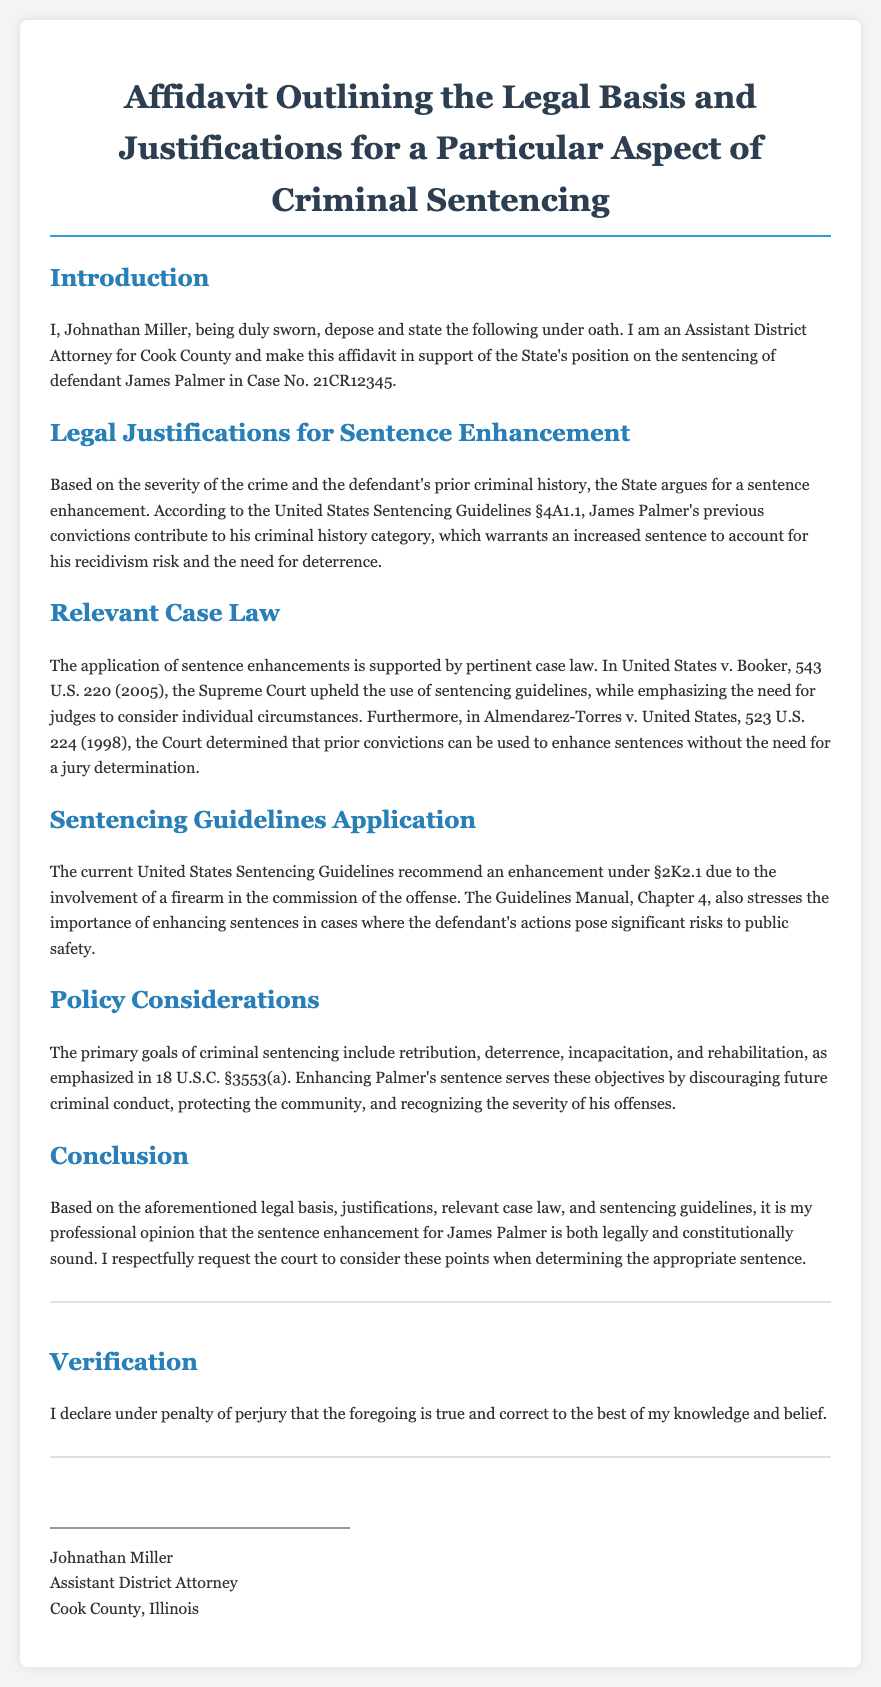What is the name of the affiant? The affiant, who makes this affidavit, is introduced in the document as Johnathan Miller.
Answer: Johnathan Miller What case number is associated with the defendant? The case number mentioned in the affidavit is specifically stated in the introduction section.
Answer: 21CR12345 Which sentencing guidelines section relates to criminal history category? The relevant sentencing guidelines section that addresses criminal history category is indicated in the section discussing sentence enhancement.
Answer: §4A1.1 What Supreme Court case supports the use of sentencing guidelines? The affidavit references a specific Supreme Court case that upholds the application of sentencing guidelines for legal justification.
Answer: United States v. Booker What enhancement is recommended under the United States Sentencing Guidelines? The enhancement mentioned in the context of the sentencing guidelines due to firearm involvement is specified in the relevant section of the affidavit.
Answer: §2K2.1 What is one of the primary goals of criminal sentencing mentioned? The document outlines several goals of criminal sentencing as part of the policy considerations; one of these goals is explicitly mentioned.
Answer: Deterrence Who is the affiant's profession? The profession of the affiant is clearly stated at the beginning of the document, helping to establish credibility.
Answer: Assistant District Attorney What must the court consider when determining the appropriate sentence? The conclusion of the affidavit emphasizes the considerations that the court should take into account regarding sentencing.
Answer: Legal basis, justifications, case law, sentencing guidelines 